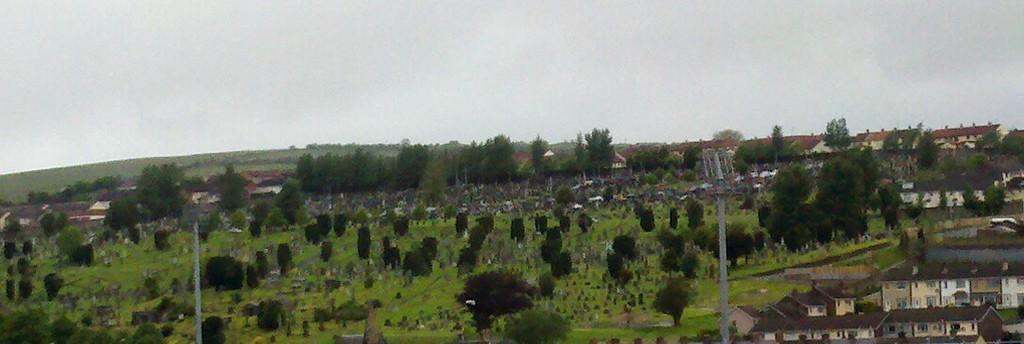What type of structures can be seen in the image? There are houses in the image. What type of vegetation is present in the image? There are trees and grass in the image. What type of berry can be seen growing on the trees in the image? There are no berries visible on the trees in the image; only trees and grass are present. How many legs can be seen on the houses in the image? Houses do not have legs, so this question cannot be answered based on the image. 